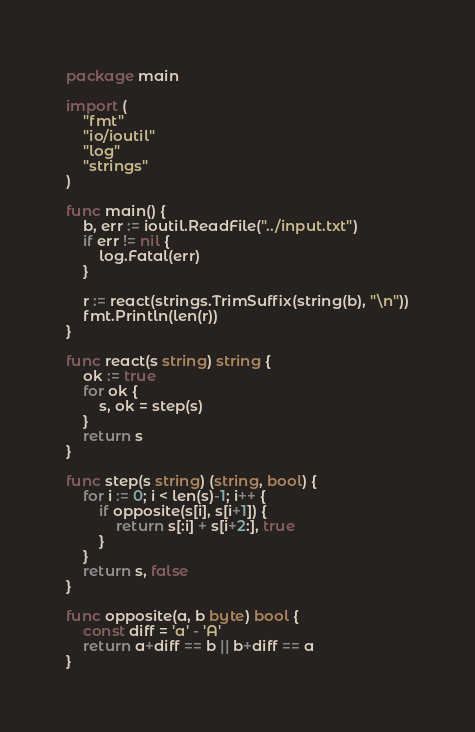Convert code to text. <code><loc_0><loc_0><loc_500><loc_500><_Go_>package main

import (
	"fmt"
	"io/ioutil"
	"log"
	"strings"
)

func main() {
	b, err := ioutil.ReadFile("../input.txt")
	if err != nil {
		log.Fatal(err)
	}

	r := react(strings.TrimSuffix(string(b), "\n"))
	fmt.Println(len(r))
}

func react(s string) string {
	ok := true
	for ok {
		s, ok = step(s)
	}
	return s
}

func step(s string) (string, bool) {
	for i := 0; i < len(s)-1; i++ {
		if opposite(s[i], s[i+1]) {
			return s[:i] + s[i+2:], true
		}
	}
	return s, false
}

func opposite(a, b byte) bool {
	const diff = 'a' - 'A'
	return a+diff == b || b+diff == a
}
</code> 